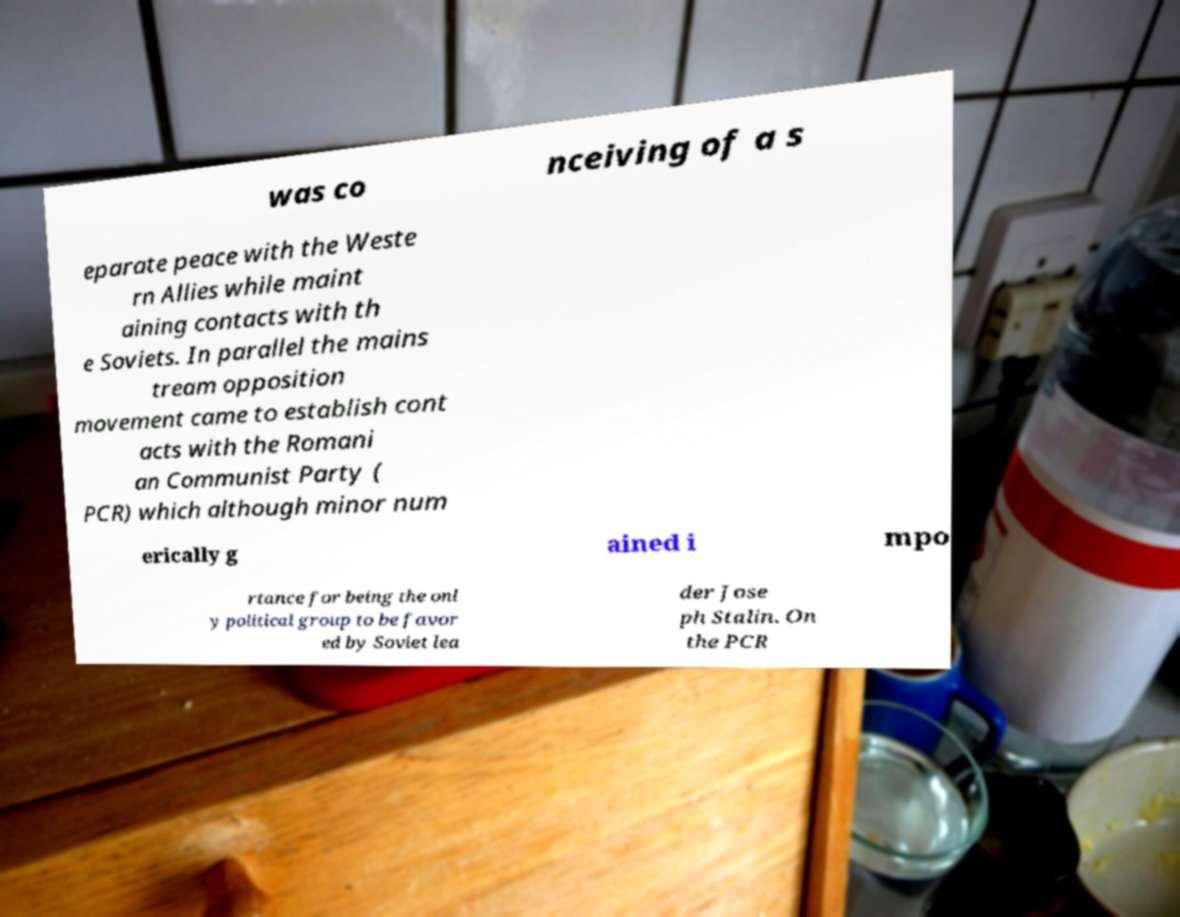Can you read and provide the text displayed in the image?This photo seems to have some interesting text. Can you extract and type it out for me? was co nceiving of a s eparate peace with the Weste rn Allies while maint aining contacts with th e Soviets. In parallel the mains tream opposition movement came to establish cont acts with the Romani an Communist Party ( PCR) which although minor num erically g ained i mpo rtance for being the onl y political group to be favor ed by Soviet lea der Jose ph Stalin. On the PCR 